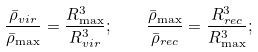<formula> <loc_0><loc_0><loc_500><loc_500>\frac { \bar { \rho } _ { v i r } } { \bar { \rho } _ { \max } } = \frac { R _ { \max } ^ { 3 } } { R _ { v i r } ^ { 3 } } ; \quad \frac { \bar { \rho } _ { \max } } { \bar { \rho } _ { r e c } } = \frac { R _ { r e c } ^ { 3 } } { R _ { \max } ^ { 3 } } ;</formula> 